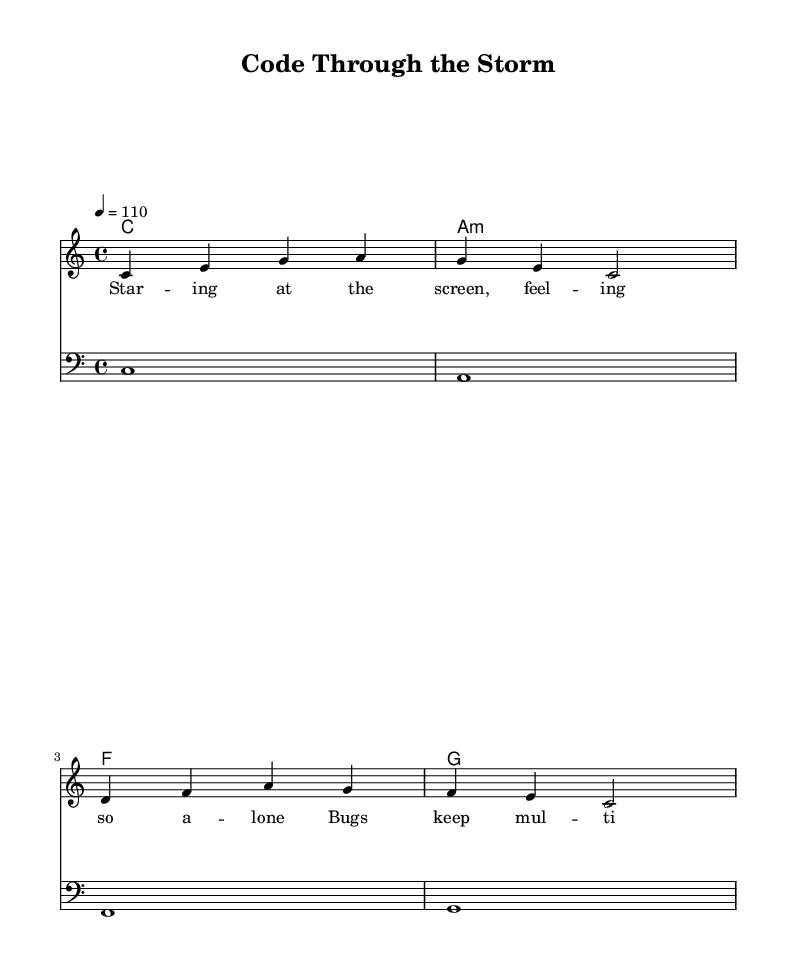What is the key signature of this music? The key signature is noted at the beginning of the score and indicates C major, which has no sharps or flats.
Answer: C major What is the time signature of this piece? The time signature can be found in the header section at the beginning of the score, indicating a 4/4 time, which means four beats per measure.
Answer: 4/4 What is the tempo marking of this score? The tempo marking is specified in the global section, set to quarter note equals 110 beats per minute.
Answer: 110 How many measures are there in the melody? By examining the melody, we count the measures separated by vertical lines, which amount to four measures in total.
Answer: 4 What chords are used in the harmonies? The chords represented in the chord mode section show four distinct chords: C, A minor, F, and G.
Answer: C, A minor, F, G What is the lyrical theme of the verse? The lyrics describe a sense of isolation while coding, with references to bugs and errors, conveying the emotional struggle faced during coding challenges.
Answer: Isolation and struggle Which clef is used for the bass staff? The bass staff is clearly labeled with a bass clef symbol at the start of that system, indicating it is meant for lower pitch instruments or voices.
Answer: Bass clef 